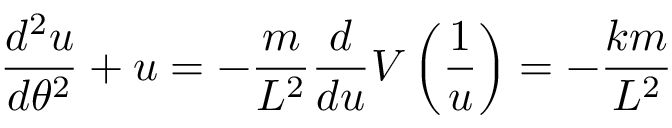Convert formula to latex. <formula><loc_0><loc_0><loc_500><loc_500>{ \frac { d ^ { 2 } u } { d \theta ^ { 2 } } } + u = - { \frac { m } { L ^ { 2 } } } { \frac { d } { d u } } V \left ( { \frac { 1 } { u } } \right ) = - { \frac { k m } { L ^ { 2 } } }</formula> 